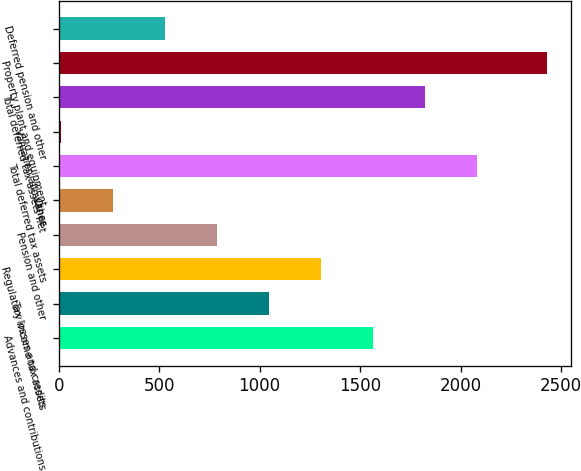<chart> <loc_0><loc_0><loc_500><loc_500><bar_chart><fcel>Advances and contributions<fcel>Tax losses and credits<fcel>Regulatory income tax assets<fcel>Pension and other<fcel>Other<fcel>Total deferred tax assets<fcel>Valuation allowance<fcel>Total deferred tax assets net<fcel>Property plant and equipment<fcel>Deferred pension and other<nl><fcel>1565.8<fcel>1048.2<fcel>1307<fcel>789.4<fcel>271.8<fcel>2083.4<fcel>13<fcel>1824.6<fcel>2429<fcel>530.6<nl></chart> 